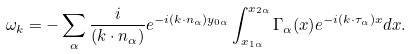<formula> <loc_0><loc_0><loc_500><loc_500>\omega _ { k } = - \sum _ { \alpha } \frac { i } { ( { k \cdot n _ { \alpha } } ) } e ^ { - i ( { k \cdot n _ { \alpha } } ) y _ { 0 \alpha } } \int _ { x _ { 1 \alpha } } ^ { x _ { 2 \alpha } } \Gamma _ { \alpha } ( x ) e ^ { - i ( { k \cdot \tau _ { \alpha } } ) x } d x .</formula> 